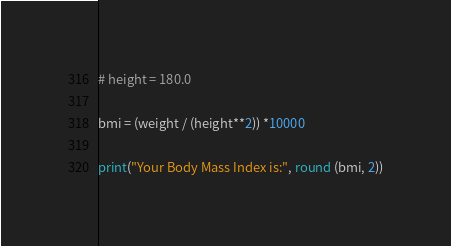<code> <loc_0><loc_0><loc_500><loc_500><_Python_># height = 180.0

bmi = (weight / (height**2)) *10000

print("Your Body Mass Index is:", round (bmi, 2))

</code> 